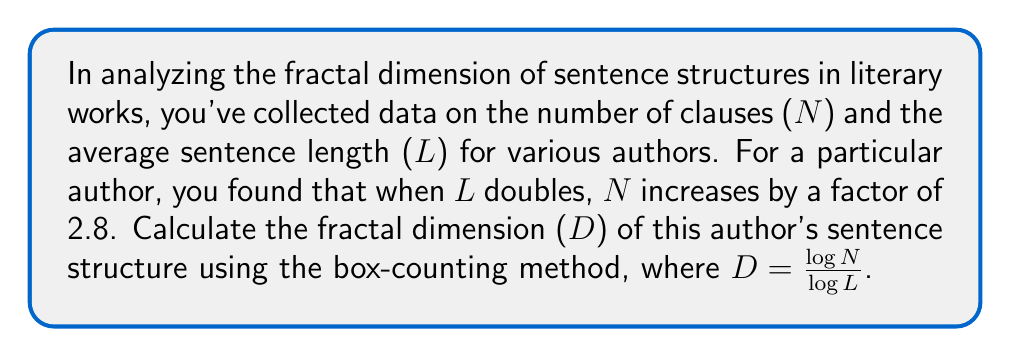Can you answer this question? To solve this problem, we'll follow these steps:

1) In the box-counting method, the fractal dimension D is given by:

   $D = \frac{\log N}{\log L}$

2) We're told that when L doubles, N increases by a factor of 2.8. Let's express this mathematically:

   If $L_2 = 2L_1$, then $N_2 = 2.8N_1$

3) We can substitute these into our fractal dimension formula:

   $D = \frac{\log (2.8N_1)}{\log (2L_1)}$

4) Using the logarithm property $\log(ab) = \log(a) + \log(b)$, we can simplify:

   $D = \frac{\log(2.8) + \log(N_1)}{\log(2) + \log(L_1)}$

5) The $\log(N_1)$ and $\log(L_1)$ terms cancel out in the numerator and denominator:

   $D = \frac{\log(2.8)}{\log(2)}$

6) Now we can calculate this:

   $D = \frac{\log(2.8)}{\log(2)} \approx 1.4854$

Thus, the fractal dimension of this author's sentence structure is approximately 1.4854.
Answer: $D \approx 1.4854$ 